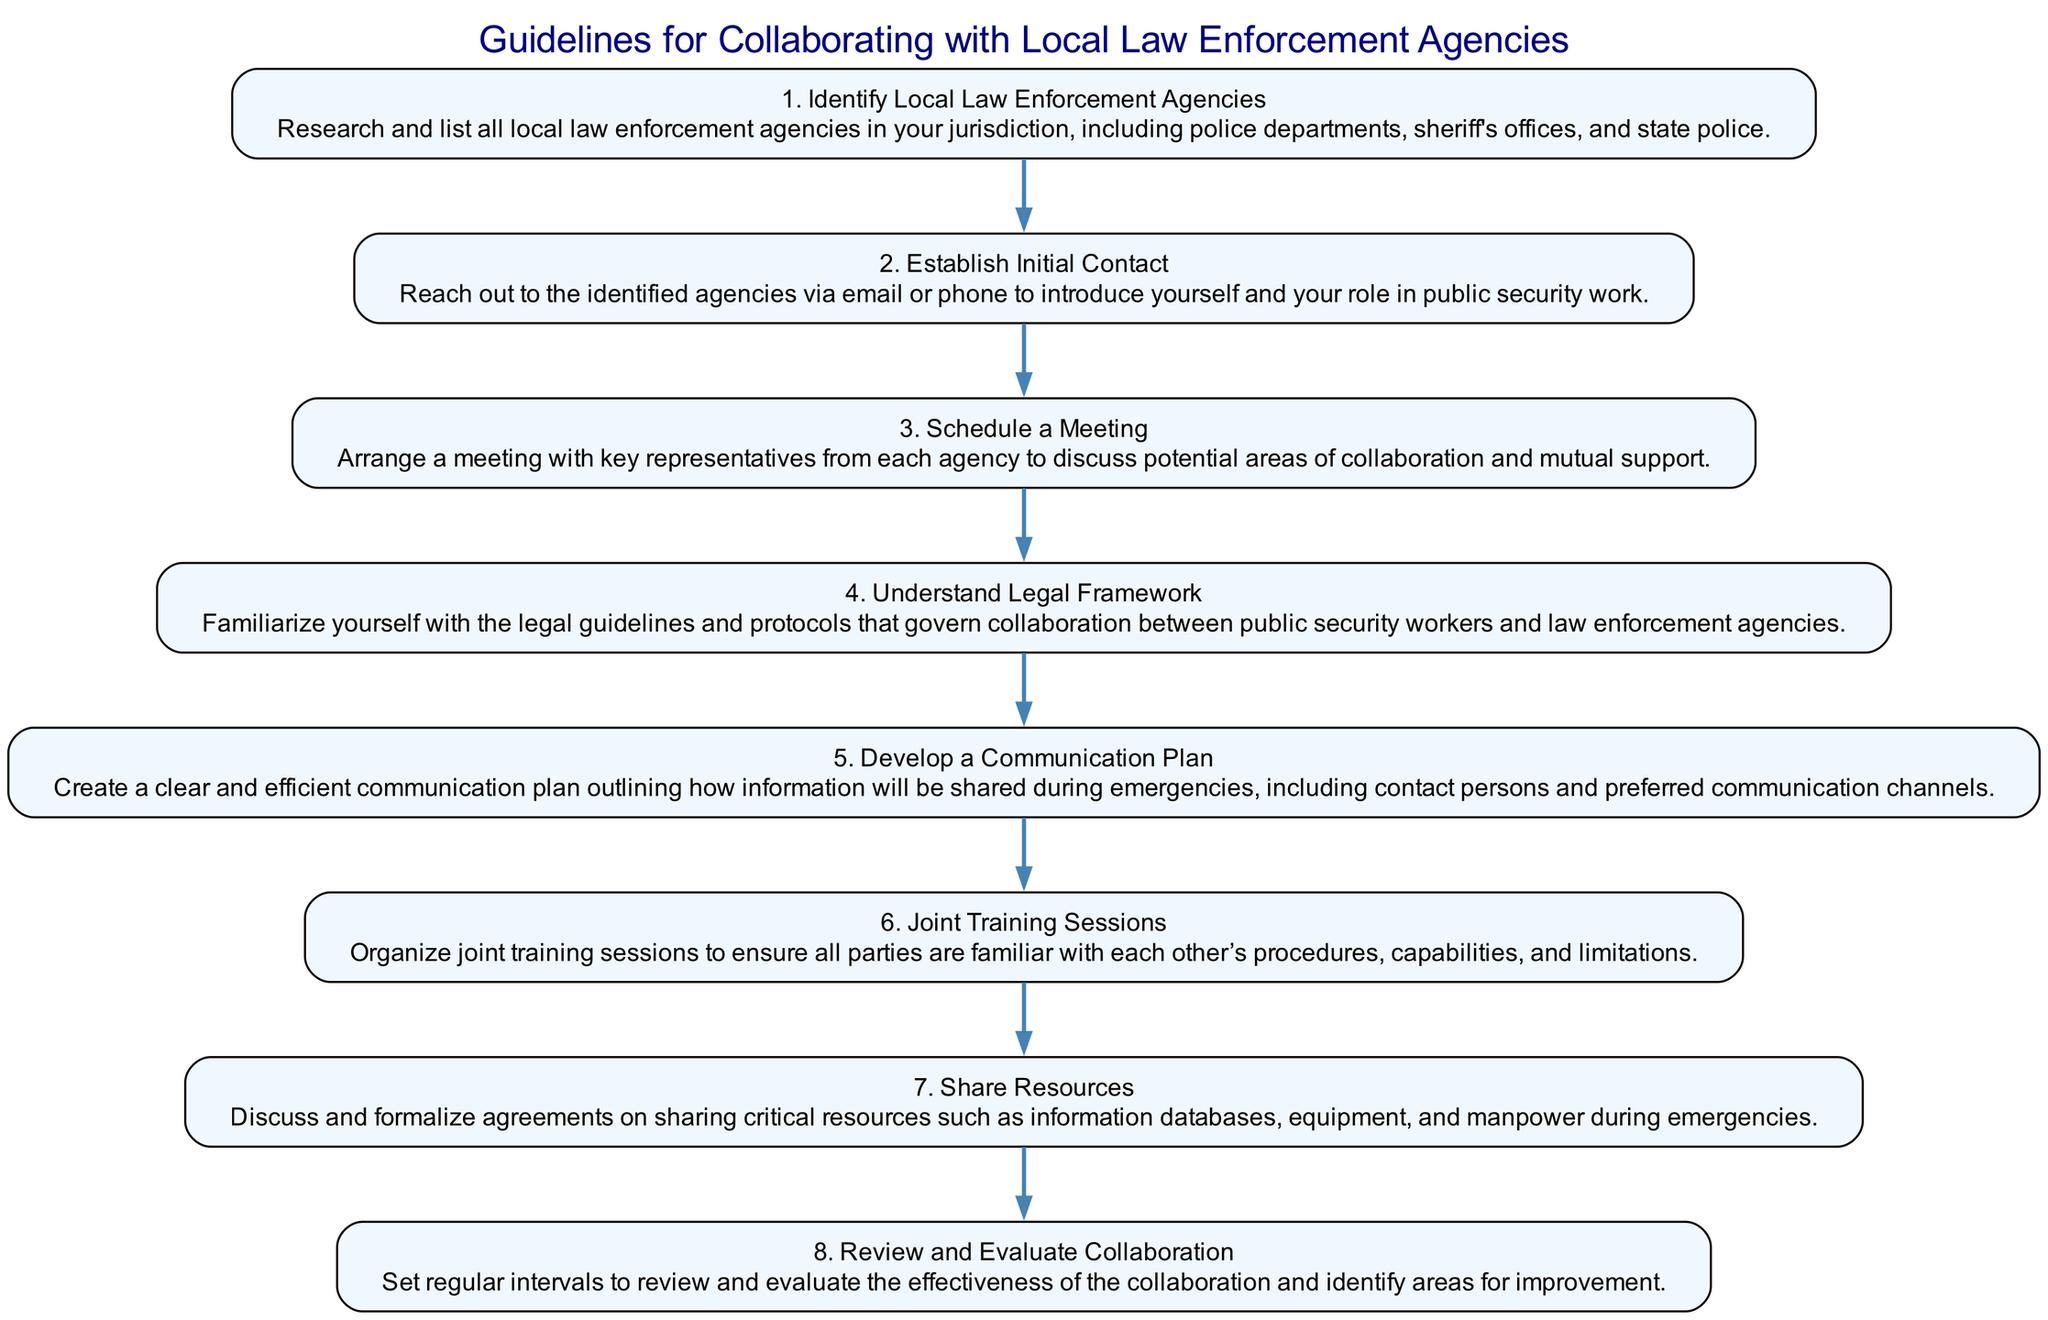What's the total number of steps in the diagram? The diagram consists of eight steps, as each step in the process is specifically labeled from one to eight.
Answer: 8 What is the first step in the collaboration process? The first step is "Identify Local Law Enforcement Agencies", which is the initial action before other steps can be taken.
Answer: Identify Local Law Enforcement Agencies What comes after "Establish Initial Contact"? The step that follows "Establish Initial Contact" is "Schedule a Meeting", indicating the next action in the flow.
Answer: Schedule a Meeting How many training sessions are mentioned in the guidelines? The diagram includes one mention of "Joint Training Sessions", indicating there is a dedicated step for this action.
Answer: Joint Training Sessions What is a key component of the "Develop a Communication Plan" step? This step emphasizes creating a communication plan that outlines how information will be shared during emergencies.
Answer: Communication Plan What are the last two steps in the guideline flow? The last two steps are "Share Resources" and "Review and Evaluate Collaboration", showing the conclusion phase of the collaboration process.
Answer: Share Resources; Review and Evaluate Collaboration Which step focuses on understanding legal guidelines? The step that focuses on legal matters is "Understand Legal Framework," highlighting the importance of being informed about regulations.
Answer: Understand Legal Framework Which steps mention evaluation or review? The steps that mention evaluation are "Review and Evaluate Collaboration," which directly addresses the need for assessment regarding the collaboration.
Answer: Review and Evaluate Collaboration 